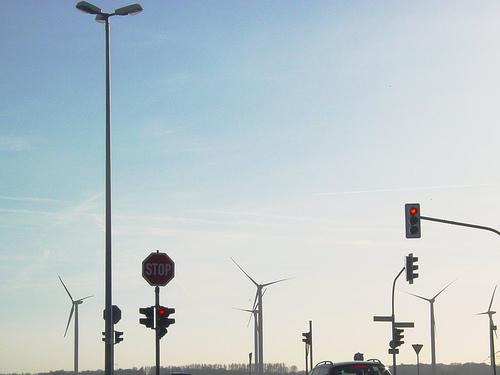The car is operating during which season? winter 